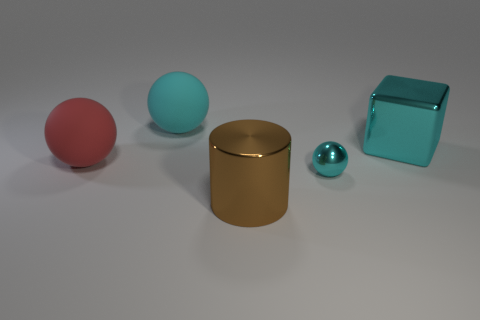Is the cyan block made of the same material as the small cyan object?
Your response must be concise. Yes. What number of blocks are large brown objects or metal objects?
Keep it short and to the point. 1. How big is the metal thing that is behind the cyan object that is in front of the large thing that is to the right of the brown metallic cylinder?
Your response must be concise. Large. There is another cyan thing that is the same shape as the large cyan matte object; what size is it?
Your answer should be very brief. Small. There is a red object; what number of red spheres are in front of it?
Provide a short and direct response. 0. Do the sphere that is to the right of the large brown shiny thing and the large cube have the same color?
Your answer should be very brief. Yes. How many green objects are big metal things or cylinders?
Your answer should be compact. 0. There is a large matte thing that is in front of the big rubber ball behind the cyan metallic block; what is its color?
Offer a terse response. Red. There is a ball that is the same color as the tiny metallic thing; what is it made of?
Provide a succinct answer. Rubber. There is a big metal object right of the large brown cylinder; what is its color?
Your response must be concise. Cyan. 